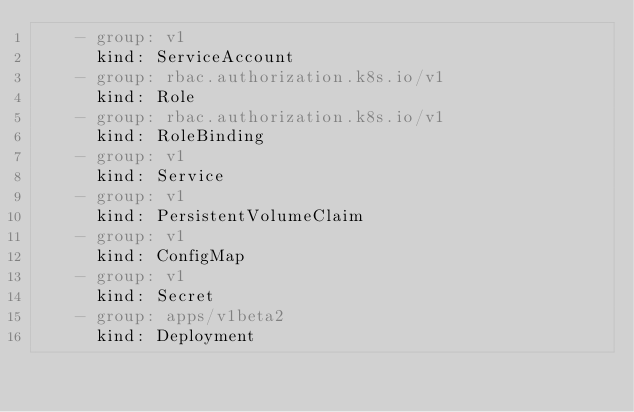Convert code to text. <code><loc_0><loc_0><loc_500><loc_500><_YAML_>    - group: v1
      kind: ServiceAccount
    - group: rbac.authorization.k8s.io/v1
      kind: Role
    - group: rbac.authorization.k8s.io/v1
      kind: RoleBinding
    - group: v1
      kind: Service
    - group: v1
      kind: PersistentVolumeClaim
    - group: v1
      kind: ConfigMap
    - group: v1
      kind: Secret
    - group: apps/v1beta2
      kind: Deployment

</code> 